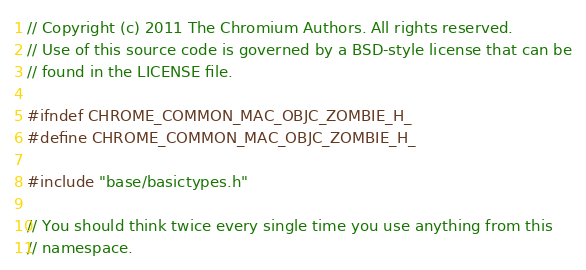<code> <loc_0><loc_0><loc_500><loc_500><_C_>// Copyright (c) 2011 The Chromium Authors. All rights reserved.
// Use of this source code is governed by a BSD-style license that can be
// found in the LICENSE file.

#ifndef CHROME_COMMON_MAC_OBJC_ZOMBIE_H_
#define CHROME_COMMON_MAC_OBJC_ZOMBIE_H_

#include "base/basictypes.h"

// You should think twice every single time you use anything from this
// namespace.</code> 